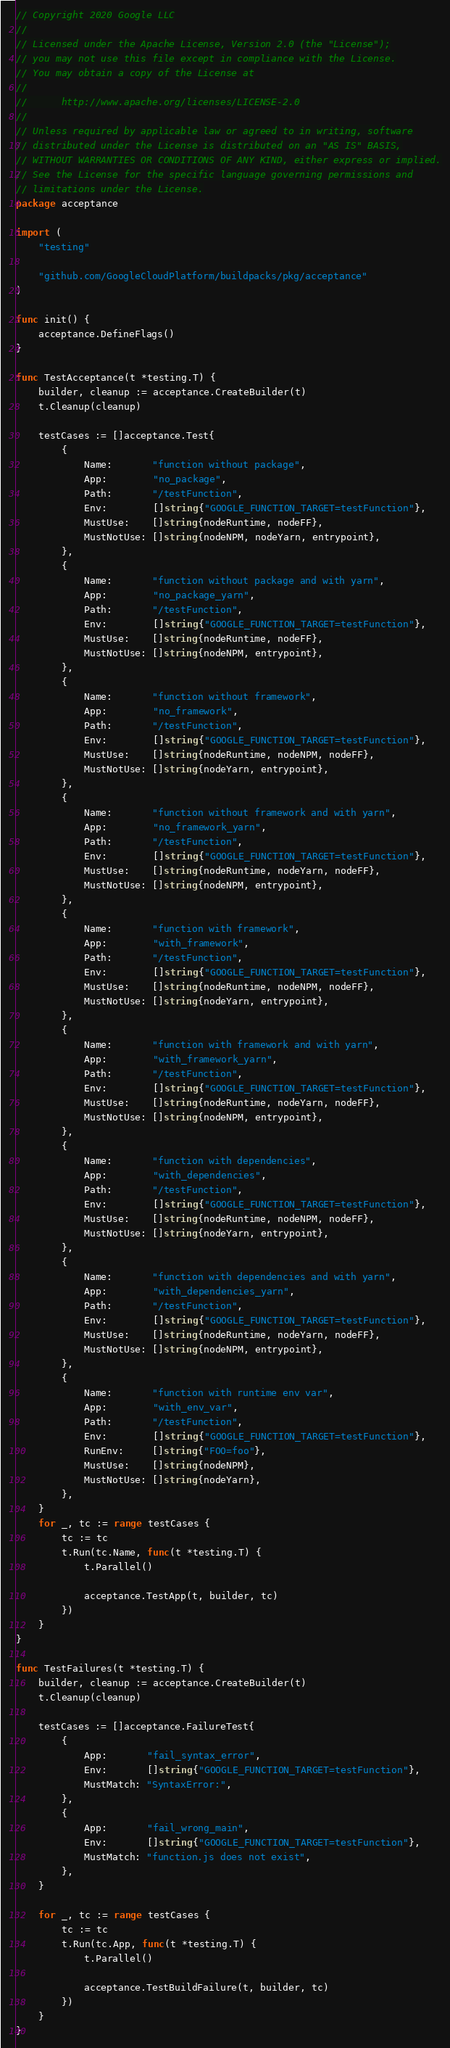<code> <loc_0><loc_0><loc_500><loc_500><_Go_>// Copyright 2020 Google LLC
//
// Licensed under the Apache License, Version 2.0 (the "License");
// you may not use this file except in compliance with the License.
// You may obtain a copy of the License at
//
//      http://www.apache.org/licenses/LICENSE-2.0
//
// Unless required by applicable law or agreed to in writing, software
// distributed under the License is distributed on an "AS IS" BASIS,
// WITHOUT WARRANTIES OR CONDITIONS OF ANY KIND, either express or implied.
// See the License for the specific language governing permissions and
// limitations under the License.
package acceptance

import (
	"testing"

	"github.com/GoogleCloudPlatform/buildpacks/pkg/acceptance"
)

func init() {
	acceptance.DefineFlags()
}

func TestAcceptance(t *testing.T) {
	builder, cleanup := acceptance.CreateBuilder(t)
	t.Cleanup(cleanup)

	testCases := []acceptance.Test{
		{
			Name:       "function without package",
			App:        "no_package",
			Path:       "/testFunction",
			Env:        []string{"GOOGLE_FUNCTION_TARGET=testFunction"},
			MustUse:    []string{nodeRuntime, nodeFF},
			MustNotUse: []string{nodeNPM, nodeYarn, entrypoint},
		},
		{
			Name:       "function without package and with yarn",
			App:        "no_package_yarn",
			Path:       "/testFunction",
			Env:        []string{"GOOGLE_FUNCTION_TARGET=testFunction"},
			MustUse:    []string{nodeRuntime, nodeFF},
			MustNotUse: []string{nodeNPM, entrypoint},
		},
		{
			Name:       "function without framework",
			App:        "no_framework",
			Path:       "/testFunction",
			Env:        []string{"GOOGLE_FUNCTION_TARGET=testFunction"},
			MustUse:    []string{nodeRuntime, nodeNPM, nodeFF},
			MustNotUse: []string{nodeYarn, entrypoint},
		},
		{
			Name:       "function without framework and with yarn",
			App:        "no_framework_yarn",
			Path:       "/testFunction",
			Env:        []string{"GOOGLE_FUNCTION_TARGET=testFunction"},
			MustUse:    []string{nodeRuntime, nodeYarn, nodeFF},
			MustNotUse: []string{nodeNPM, entrypoint},
		},
		{
			Name:       "function with framework",
			App:        "with_framework",
			Path:       "/testFunction",
			Env:        []string{"GOOGLE_FUNCTION_TARGET=testFunction"},
			MustUse:    []string{nodeRuntime, nodeNPM, nodeFF},
			MustNotUse: []string{nodeYarn, entrypoint},
		},
		{
			Name:       "function with framework and with yarn",
			App:        "with_framework_yarn",
			Path:       "/testFunction",
			Env:        []string{"GOOGLE_FUNCTION_TARGET=testFunction"},
			MustUse:    []string{nodeRuntime, nodeYarn, nodeFF},
			MustNotUse: []string{nodeNPM, entrypoint},
		},
		{
			Name:       "function with dependencies",
			App:        "with_dependencies",
			Path:       "/testFunction",
			Env:        []string{"GOOGLE_FUNCTION_TARGET=testFunction"},
			MustUse:    []string{nodeRuntime, nodeNPM, nodeFF},
			MustNotUse: []string{nodeYarn, entrypoint},
		},
		{
			Name:       "function with dependencies and with yarn",
			App:        "with_dependencies_yarn",
			Path:       "/testFunction",
			Env:        []string{"GOOGLE_FUNCTION_TARGET=testFunction"},
			MustUse:    []string{nodeRuntime, nodeYarn, nodeFF},
			MustNotUse: []string{nodeNPM, entrypoint},
		},
		{
			Name:       "function with runtime env var",
			App:        "with_env_var",
			Path:       "/testFunction",
			Env:        []string{"GOOGLE_FUNCTION_TARGET=testFunction"},
			RunEnv:     []string{"FOO=foo"},
			MustUse:    []string{nodeNPM},
			MustNotUse: []string{nodeYarn},
		},
	}
	for _, tc := range testCases {
		tc := tc
		t.Run(tc.Name, func(t *testing.T) {
			t.Parallel()

			acceptance.TestApp(t, builder, tc)
		})
	}
}

func TestFailures(t *testing.T) {
	builder, cleanup := acceptance.CreateBuilder(t)
	t.Cleanup(cleanup)

	testCases := []acceptance.FailureTest{
		{
			App:       "fail_syntax_error",
			Env:       []string{"GOOGLE_FUNCTION_TARGET=testFunction"},
			MustMatch: "SyntaxError:",
		},
		{
			App:       "fail_wrong_main",
			Env:       []string{"GOOGLE_FUNCTION_TARGET=testFunction"},
			MustMatch: "function.js does not exist",
		},
	}

	for _, tc := range testCases {
		tc := tc
		t.Run(tc.App, func(t *testing.T) {
			t.Parallel()

			acceptance.TestBuildFailure(t, builder, tc)
		})
	}
}
</code> 